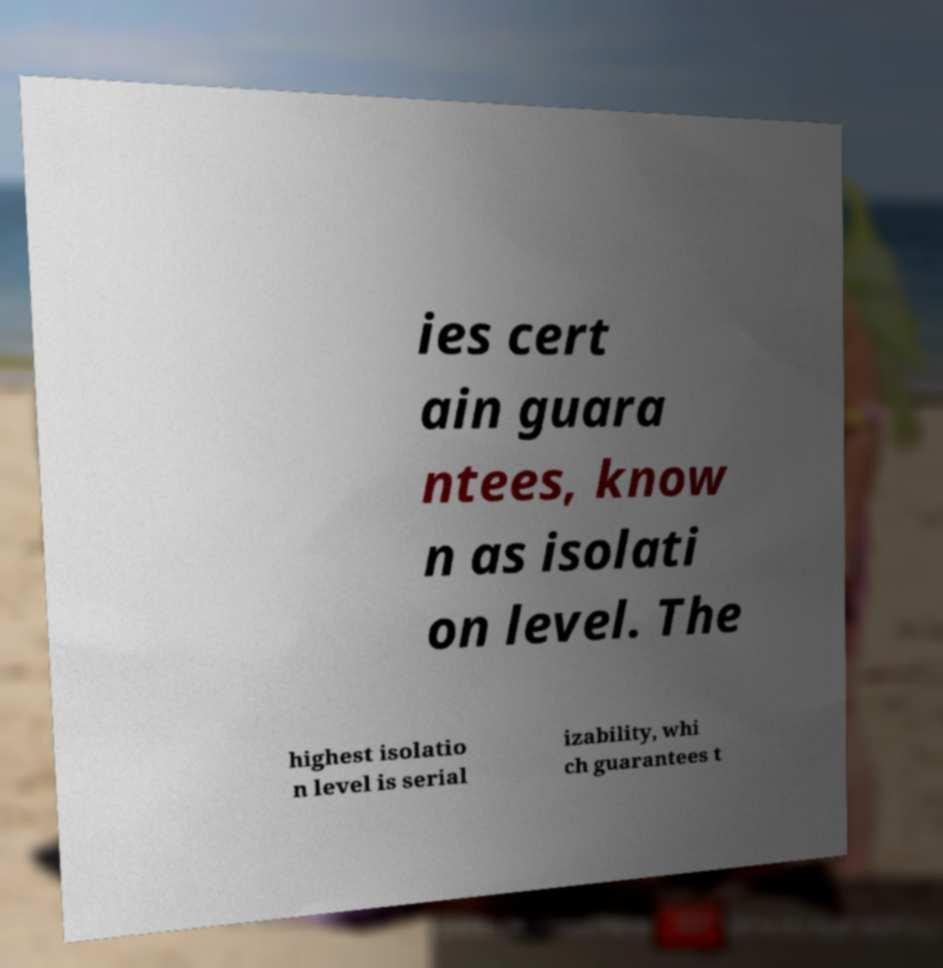Could you assist in decoding the text presented in this image and type it out clearly? ies cert ain guara ntees, know n as isolati on level. The highest isolatio n level is serial izability, whi ch guarantees t 